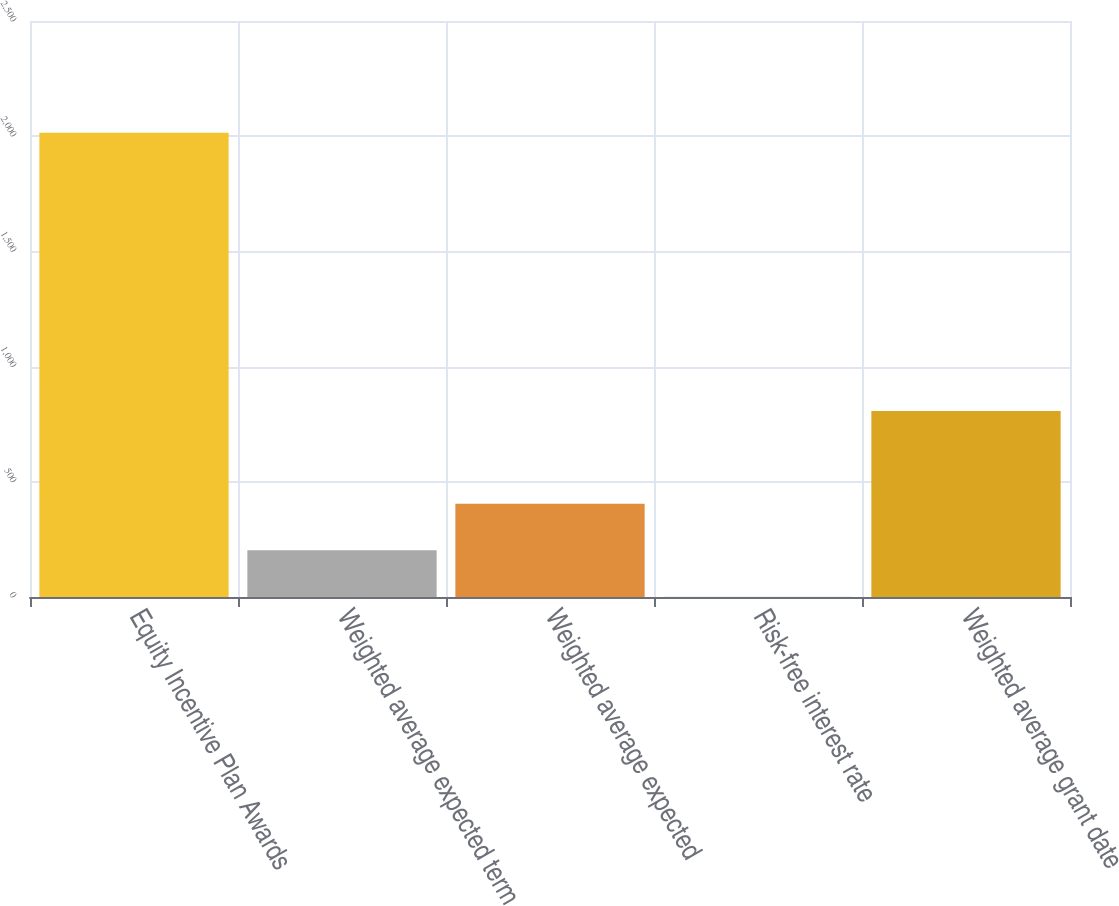Convert chart to OTSL. <chart><loc_0><loc_0><loc_500><loc_500><bar_chart><fcel>Equity Incentive Plan Awards<fcel>Weighted average expected term<fcel>Weighted average expected<fcel>Risk-free interest rate<fcel>Weighted average grant date<nl><fcel>2015<fcel>202.84<fcel>404.19<fcel>1.49<fcel>806.89<nl></chart> 